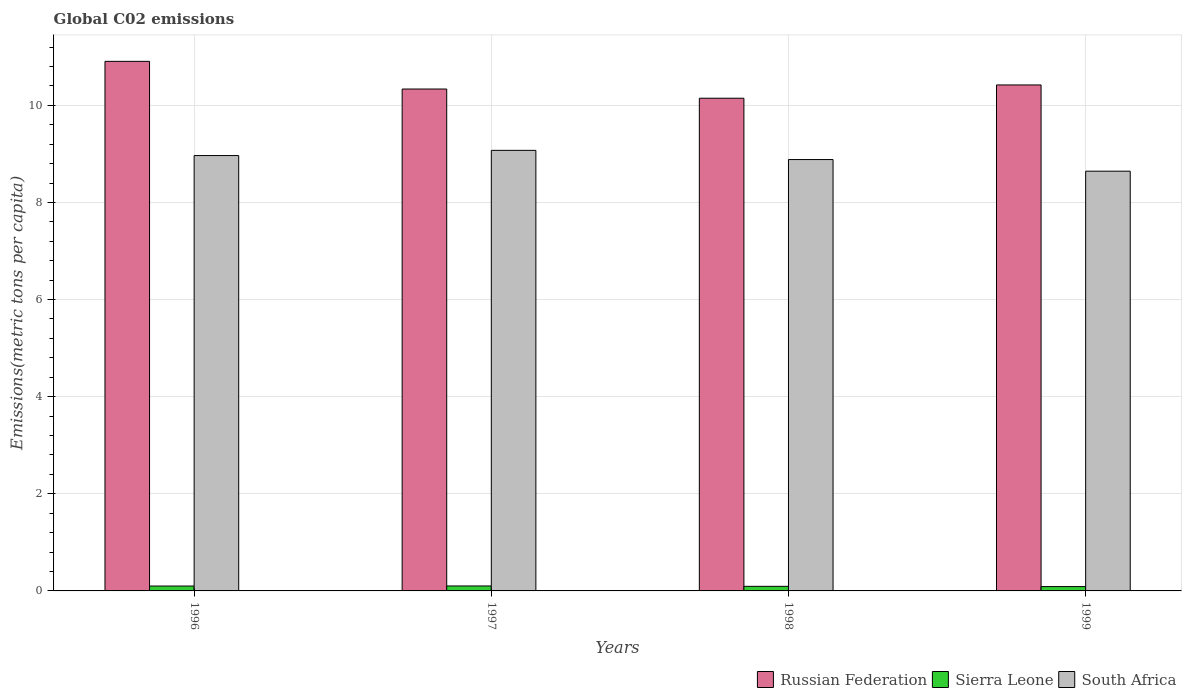Are the number of bars on each tick of the X-axis equal?
Give a very brief answer. Yes. How many bars are there on the 4th tick from the left?
Your answer should be compact. 3. How many bars are there on the 2nd tick from the right?
Offer a terse response. 3. What is the label of the 4th group of bars from the left?
Offer a very short reply. 1999. In how many cases, is the number of bars for a given year not equal to the number of legend labels?
Your answer should be compact. 0. What is the amount of CO2 emitted in in South Africa in 1999?
Provide a short and direct response. 8.64. Across all years, what is the maximum amount of CO2 emitted in in Sierra Leone?
Provide a succinct answer. 0.1. Across all years, what is the minimum amount of CO2 emitted in in Russian Federation?
Your answer should be compact. 10.15. What is the total amount of CO2 emitted in in Russian Federation in the graph?
Your answer should be compact. 41.81. What is the difference between the amount of CO2 emitted in in Russian Federation in 1997 and that in 1998?
Your answer should be very brief. 0.19. What is the difference between the amount of CO2 emitted in in Sierra Leone in 1999 and the amount of CO2 emitted in in South Africa in 1996?
Your answer should be very brief. -8.88. What is the average amount of CO2 emitted in in Russian Federation per year?
Your response must be concise. 10.45. In the year 1996, what is the difference between the amount of CO2 emitted in in South Africa and amount of CO2 emitted in in Sierra Leone?
Provide a succinct answer. 8.87. In how many years, is the amount of CO2 emitted in in Sierra Leone greater than 0.4 metric tons per capita?
Provide a short and direct response. 0. What is the ratio of the amount of CO2 emitted in in South Africa in 1996 to that in 1998?
Your response must be concise. 1.01. What is the difference between the highest and the second highest amount of CO2 emitted in in Sierra Leone?
Provide a short and direct response. 0. What is the difference between the highest and the lowest amount of CO2 emitted in in Sierra Leone?
Your response must be concise. 0.01. What does the 1st bar from the left in 1998 represents?
Your answer should be very brief. Russian Federation. What does the 2nd bar from the right in 1997 represents?
Offer a terse response. Sierra Leone. How many bars are there?
Provide a succinct answer. 12. Where does the legend appear in the graph?
Keep it short and to the point. Bottom right. What is the title of the graph?
Keep it short and to the point. Global C02 emissions. Does "Comoros" appear as one of the legend labels in the graph?
Provide a succinct answer. No. What is the label or title of the X-axis?
Your answer should be very brief. Years. What is the label or title of the Y-axis?
Keep it short and to the point. Emissions(metric tons per capita). What is the Emissions(metric tons per capita) in Russian Federation in 1996?
Make the answer very short. 10.91. What is the Emissions(metric tons per capita) of Sierra Leone in 1996?
Your answer should be very brief. 0.1. What is the Emissions(metric tons per capita) of South Africa in 1996?
Provide a succinct answer. 8.97. What is the Emissions(metric tons per capita) of Russian Federation in 1997?
Provide a succinct answer. 10.34. What is the Emissions(metric tons per capita) of Sierra Leone in 1997?
Provide a succinct answer. 0.1. What is the Emissions(metric tons per capita) in South Africa in 1997?
Offer a terse response. 9.07. What is the Emissions(metric tons per capita) of Russian Federation in 1998?
Give a very brief answer. 10.15. What is the Emissions(metric tons per capita) in Sierra Leone in 1998?
Ensure brevity in your answer.  0.09. What is the Emissions(metric tons per capita) of South Africa in 1998?
Keep it short and to the point. 8.88. What is the Emissions(metric tons per capita) in Russian Federation in 1999?
Your answer should be compact. 10.42. What is the Emissions(metric tons per capita) of Sierra Leone in 1999?
Provide a succinct answer. 0.09. What is the Emissions(metric tons per capita) of South Africa in 1999?
Ensure brevity in your answer.  8.64. Across all years, what is the maximum Emissions(metric tons per capita) in Russian Federation?
Offer a terse response. 10.91. Across all years, what is the maximum Emissions(metric tons per capita) in Sierra Leone?
Your answer should be very brief. 0.1. Across all years, what is the maximum Emissions(metric tons per capita) of South Africa?
Offer a very short reply. 9.07. Across all years, what is the minimum Emissions(metric tons per capita) of Russian Federation?
Your answer should be very brief. 10.15. Across all years, what is the minimum Emissions(metric tons per capita) of Sierra Leone?
Ensure brevity in your answer.  0.09. Across all years, what is the minimum Emissions(metric tons per capita) of South Africa?
Offer a very short reply. 8.64. What is the total Emissions(metric tons per capita) of Russian Federation in the graph?
Offer a very short reply. 41.81. What is the total Emissions(metric tons per capita) of Sierra Leone in the graph?
Ensure brevity in your answer.  0.39. What is the total Emissions(metric tons per capita) in South Africa in the graph?
Provide a short and direct response. 35.57. What is the difference between the Emissions(metric tons per capita) in Russian Federation in 1996 and that in 1997?
Offer a terse response. 0.57. What is the difference between the Emissions(metric tons per capita) in Sierra Leone in 1996 and that in 1997?
Make the answer very short. -0. What is the difference between the Emissions(metric tons per capita) in South Africa in 1996 and that in 1997?
Ensure brevity in your answer.  -0.11. What is the difference between the Emissions(metric tons per capita) in Russian Federation in 1996 and that in 1998?
Give a very brief answer. 0.76. What is the difference between the Emissions(metric tons per capita) in Sierra Leone in 1996 and that in 1998?
Offer a very short reply. 0.01. What is the difference between the Emissions(metric tons per capita) of South Africa in 1996 and that in 1998?
Keep it short and to the point. 0.08. What is the difference between the Emissions(metric tons per capita) in Russian Federation in 1996 and that in 1999?
Offer a very short reply. 0.49. What is the difference between the Emissions(metric tons per capita) of Sierra Leone in 1996 and that in 1999?
Offer a very short reply. 0.01. What is the difference between the Emissions(metric tons per capita) in South Africa in 1996 and that in 1999?
Keep it short and to the point. 0.32. What is the difference between the Emissions(metric tons per capita) in Russian Federation in 1997 and that in 1998?
Offer a very short reply. 0.19. What is the difference between the Emissions(metric tons per capita) of Sierra Leone in 1997 and that in 1998?
Provide a succinct answer. 0.01. What is the difference between the Emissions(metric tons per capita) in South Africa in 1997 and that in 1998?
Provide a short and direct response. 0.19. What is the difference between the Emissions(metric tons per capita) of Russian Federation in 1997 and that in 1999?
Offer a terse response. -0.08. What is the difference between the Emissions(metric tons per capita) of Sierra Leone in 1997 and that in 1999?
Your response must be concise. 0.01. What is the difference between the Emissions(metric tons per capita) in South Africa in 1997 and that in 1999?
Ensure brevity in your answer.  0.43. What is the difference between the Emissions(metric tons per capita) of Russian Federation in 1998 and that in 1999?
Make the answer very short. -0.27. What is the difference between the Emissions(metric tons per capita) of Sierra Leone in 1998 and that in 1999?
Provide a short and direct response. 0.01. What is the difference between the Emissions(metric tons per capita) in South Africa in 1998 and that in 1999?
Offer a terse response. 0.24. What is the difference between the Emissions(metric tons per capita) in Russian Federation in 1996 and the Emissions(metric tons per capita) in Sierra Leone in 1997?
Provide a short and direct response. 10.8. What is the difference between the Emissions(metric tons per capita) in Russian Federation in 1996 and the Emissions(metric tons per capita) in South Africa in 1997?
Keep it short and to the point. 1.83. What is the difference between the Emissions(metric tons per capita) of Sierra Leone in 1996 and the Emissions(metric tons per capita) of South Africa in 1997?
Offer a very short reply. -8.97. What is the difference between the Emissions(metric tons per capita) of Russian Federation in 1996 and the Emissions(metric tons per capita) of Sierra Leone in 1998?
Give a very brief answer. 10.81. What is the difference between the Emissions(metric tons per capita) in Russian Federation in 1996 and the Emissions(metric tons per capita) in South Africa in 1998?
Provide a short and direct response. 2.02. What is the difference between the Emissions(metric tons per capita) in Sierra Leone in 1996 and the Emissions(metric tons per capita) in South Africa in 1998?
Your answer should be compact. -8.78. What is the difference between the Emissions(metric tons per capita) of Russian Federation in 1996 and the Emissions(metric tons per capita) of Sierra Leone in 1999?
Ensure brevity in your answer.  10.82. What is the difference between the Emissions(metric tons per capita) in Russian Federation in 1996 and the Emissions(metric tons per capita) in South Africa in 1999?
Provide a short and direct response. 2.26. What is the difference between the Emissions(metric tons per capita) of Sierra Leone in 1996 and the Emissions(metric tons per capita) of South Africa in 1999?
Your answer should be compact. -8.54. What is the difference between the Emissions(metric tons per capita) of Russian Federation in 1997 and the Emissions(metric tons per capita) of Sierra Leone in 1998?
Your response must be concise. 10.24. What is the difference between the Emissions(metric tons per capita) in Russian Federation in 1997 and the Emissions(metric tons per capita) in South Africa in 1998?
Keep it short and to the point. 1.45. What is the difference between the Emissions(metric tons per capita) of Sierra Leone in 1997 and the Emissions(metric tons per capita) of South Africa in 1998?
Offer a terse response. -8.78. What is the difference between the Emissions(metric tons per capita) of Russian Federation in 1997 and the Emissions(metric tons per capita) of Sierra Leone in 1999?
Your response must be concise. 10.25. What is the difference between the Emissions(metric tons per capita) in Russian Federation in 1997 and the Emissions(metric tons per capita) in South Africa in 1999?
Your answer should be very brief. 1.69. What is the difference between the Emissions(metric tons per capita) of Sierra Leone in 1997 and the Emissions(metric tons per capita) of South Africa in 1999?
Ensure brevity in your answer.  -8.54. What is the difference between the Emissions(metric tons per capita) of Russian Federation in 1998 and the Emissions(metric tons per capita) of Sierra Leone in 1999?
Keep it short and to the point. 10.06. What is the difference between the Emissions(metric tons per capita) in Russian Federation in 1998 and the Emissions(metric tons per capita) in South Africa in 1999?
Ensure brevity in your answer.  1.5. What is the difference between the Emissions(metric tons per capita) of Sierra Leone in 1998 and the Emissions(metric tons per capita) of South Africa in 1999?
Your answer should be compact. -8.55. What is the average Emissions(metric tons per capita) of Russian Federation per year?
Offer a terse response. 10.45. What is the average Emissions(metric tons per capita) in Sierra Leone per year?
Your response must be concise. 0.1. What is the average Emissions(metric tons per capita) of South Africa per year?
Offer a very short reply. 8.89. In the year 1996, what is the difference between the Emissions(metric tons per capita) of Russian Federation and Emissions(metric tons per capita) of Sierra Leone?
Give a very brief answer. 10.81. In the year 1996, what is the difference between the Emissions(metric tons per capita) of Russian Federation and Emissions(metric tons per capita) of South Africa?
Your response must be concise. 1.94. In the year 1996, what is the difference between the Emissions(metric tons per capita) in Sierra Leone and Emissions(metric tons per capita) in South Africa?
Keep it short and to the point. -8.87. In the year 1997, what is the difference between the Emissions(metric tons per capita) in Russian Federation and Emissions(metric tons per capita) in Sierra Leone?
Give a very brief answer. 10.23. In the year 1997, what is the difference between the Emissions(metric tons per capita) of Russian Federation and Emissions(metric tons per capita) of South Africa?
Make the answer very short. 1.26. In the year 1997, what is the difference between the Emissions(metric tons per capita) in Sierra Leone and Emissions(metric tons per capita) in South Africa?
Offer a terse response. -8.97. In the year 1998, what is the difference between the Emissions(metric tons per capita) of Russian Federation and Emissions(metric tons per capita) of Sierra Leone?
Ensure brevity in your answer.  10.05. In the year 1998, what is the difference between the Emissions(metric tons per capita) in Russian Federation and Emissions(metric tons per capita) in South Africa?
Your answer should be compact. 1.26. In the year 1998, what is the difference between the Emissions(metric tons per capita) of Sierra Leone and Emissions(metric tons per capita) of South Africa?
Keep it short and to the point. -8.79. In the year 1999, what is the difference between the Emissions(metric tons per capita) in Russian Federation and Emissions(metric tons per capita) in Sierra Leone?
Offer a very short reply. 10.33. In the year 1999, what is the difference between the Emissions(metric tons per capita) in Russian Federation and Emissions(metric tons per capita) in South Africa?
Offer a very short reply. 1.78. In the year 1999, what is the difference between the Emissions(metric tons per capita) of Sierra Leone and Emissions(metric tons per capita) of South Africa?
Your answer should be very brief. -8.55. What is the ratio of the Emissions(metric tons per capita) of Russian Federation in 1996 to that in 1997?
Your answer should be very brief. 1.06. What is the ratio of the Emissions(metric tons per capita) in Sierra Leone in 1996 to that in 1997?
Make the answer very short. 0.98. What is the ratio of the Emissions(metric tons per capita) in Russian Federation in 1996 to that in 1998?
Offer a very short reply. 1.07. What is the ratio of the Emissions(metric tons per capita) of Sierra Leone in 1996 to that in 1998?
Your answer should be compact. 1.06. What is the ratio of the Emissions(metric tons per capita) in South Africa in 1996 to that in 1998?
Keep it short and to the point. 1.01. What is the ratio of the Emissions(metric tons per capita) in Russian Federation in 1996 to that in 1999?
Ensure brevity in your answer.  1.05. What is the ratio of the Emissions(metric tons per capita) in Sierra Leone in 1996 to that in 1999?
Make the answer very short. 1.13. What is the ratio of the Emissions(metric tons per capita) of South Africa in 1996 to that in 1999?
Your answer should be compact. 1.04. What is the ratio of the Emissions(metric tons per capita) in Russian Federation in 1997 to that in 1998?
Keep it short and to the point. 1.02. What is the ratio of the Emissions(metric tons per capita) in Sierra Leone in 1997 to that in 1998?
Give a very brief answer. 1.08. What is the ratio of the Emissions(metric tons per capita) of South Africa in 1997 to that in 1998?
Your answer should be very brief. 1.02. What is the ratio of the Emissions(metric tons per capita) of Russian Federation in 1997 to that in 1999?
Make the answer very short. 0.99. What is the ratio of the Emissions(metric tons per capita) in Sierra Leone in 1997 to that in 1999?
Provide a short and direct response. 1.15. What is the ratio of the Emissions(metric tons per capita) in South Africa in 1997 to that in 1999?
Your answer should be compact. 1.05. What is the ratio of the Emissions(metric tons per capita) of Russian Federation in 1998 to that in 1999?
Your response must be concise. 0.97. What is the ratio of the Emissions(metric tons per capita) in Sierra Leone in 1998 to that in 1999?
Make the answer very short. 1.06. What is the ratio of the Emissions(metric tons per capita) of South Africa in 1998 to that in 1999?
Provide a short and direct response. 1.03. What is the difference between the highest and the second highest Emissions(metric tons per capita) in Russian Federation?
Give a very brief answer. 0.49. What is the difference between the highest and the second highest Emissions(metric tons per capita) of Sierra Leone?
Provide a short and direct response. 0. What is the difference between the highest and the second highest Emissions(metric tons per capita) of South Africa?
Offer a very short reply. 0.11. What is the difference between the highest and the lowest Emissions(metric tons per capita) in Russian Federation?
Give a very brief answer. 0.76. What is the difference between the highest and the lowest Emissions(metric tons per capita) of Sierra Leone?
Provide a short and direct response. 0.01. What is the difference between the highest and the lowest Emissions(metric tons per capita) of South Africa?
Your response must be concise. 0.43. 